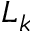Convert formula to latex. <formula><loc_0><loc_0><loc_500><loc_500>L _ { k }</formula> 